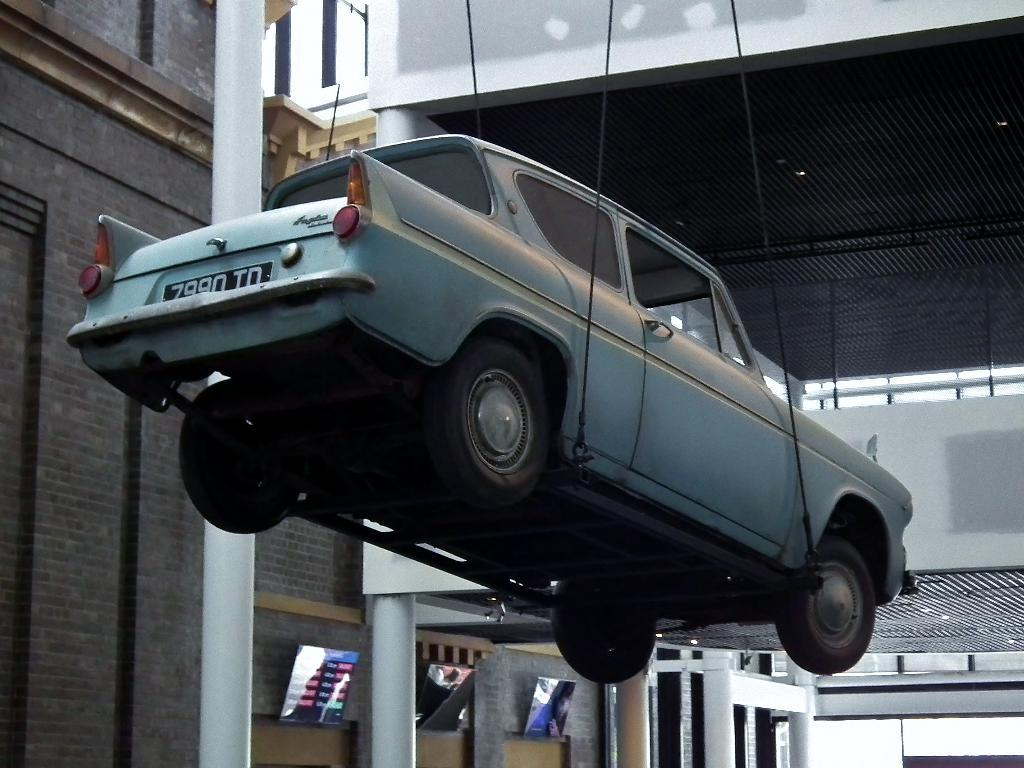What type of structure can be seen in the image? There is a shed in the image. What other type of structure is present in the image? There is a building in the image. What mode of transportation is visible in the image? There is a vehicle in the image. What type of screens are present in the image? There are screens in the image. Can you describe any other objects present in the image? There are other objects present in the image, but their specific details are not mentioned in the provided facts. Where is the knife stored in the image? There is no knife present in the image. What type of office furniture can be seen in the image? There is no office furniture present in the image. 